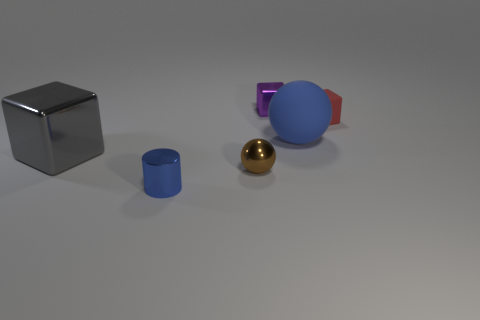Subtract all tiny blocks. How many blocks are left? 1 Subtract 2 balls. How many balls are left? 0 Add 4 blue things. How many objects exist? 10 Subtract all gray blocks. How many blocks are left? 2 Subtract all gray blocks. How many gray cylinders are left? 0 Add 5 yellow things. How many yellow things exist? 5 Subtract 0 red spheres. How many objects are left? 6 Subtract all balls. How many objects are left? 4 Subtract all purple cylinders. Subtract all gray blocks. How many cylinders are left? 1 Subtract all red blocks. Subtract all small yellow shiny balls. How many objects are left? 5 